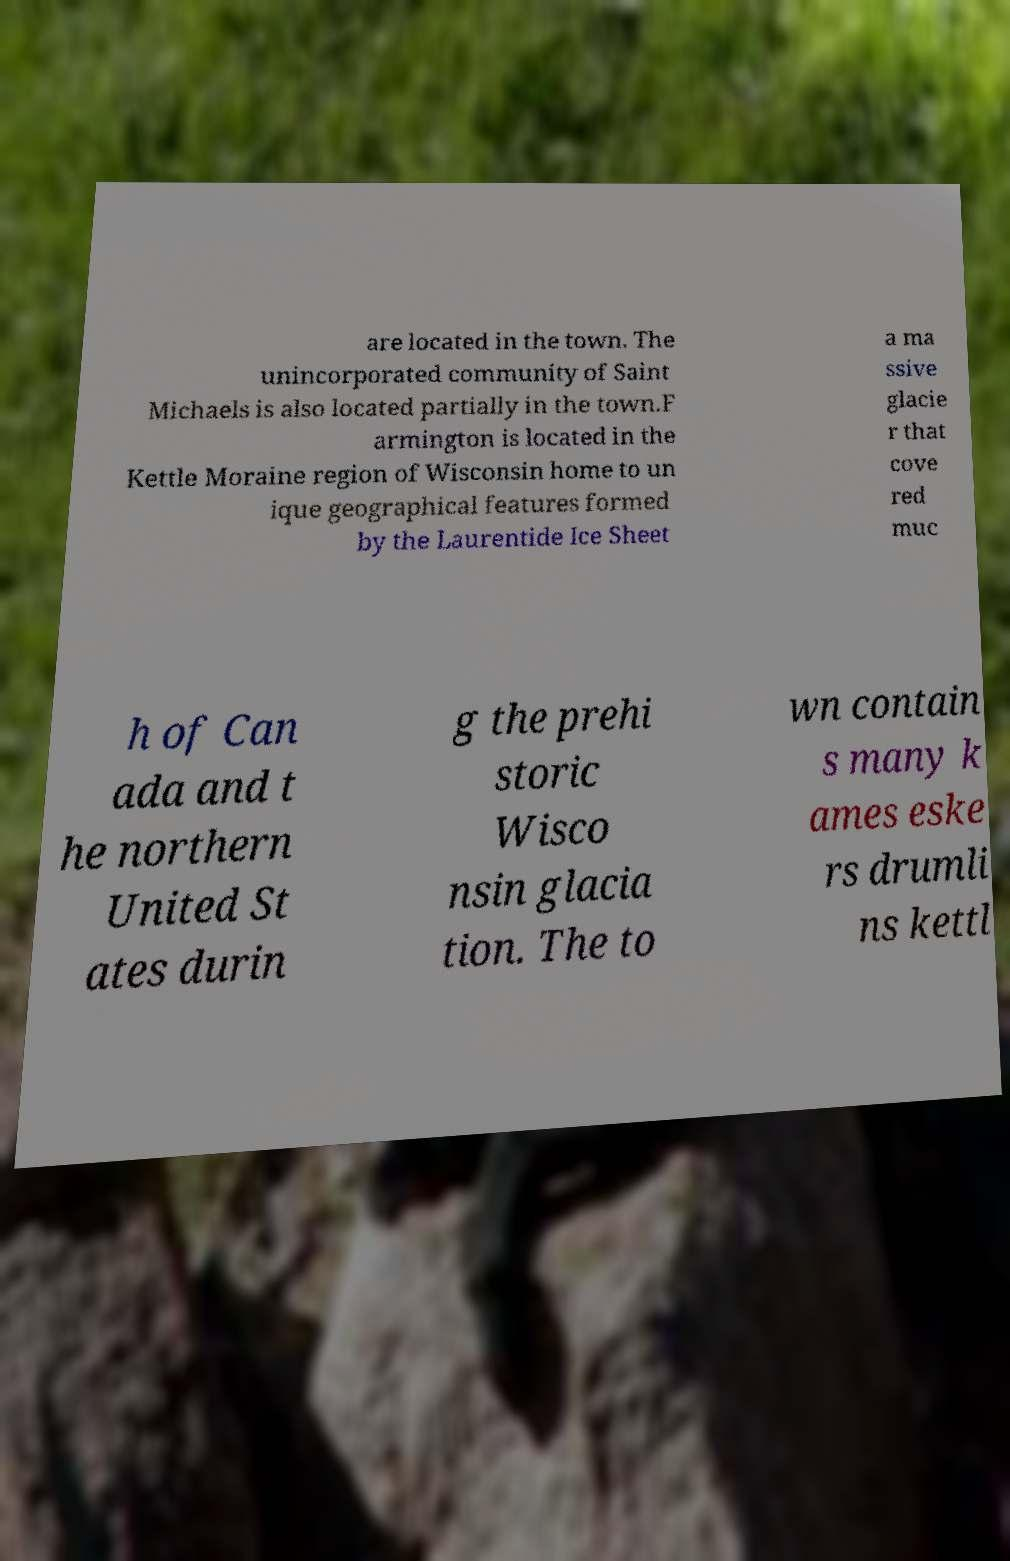I need the written content from this picture converted into text. Can you do that? are located in the town. The unincorporated community of Saint Michaels is also located partially in the town.F armington is located in the Kettle Moraine region of Wisconsin home to un ique geographical features formed by the Laurentide Ice Sheet a ma ssive glacie r that cove red muc h of Can ada and t he northern United St ates durin g the prehi storic Wisco nsin glacia tion. The to wn contain s many k ames eske rs drumli ns kettl 